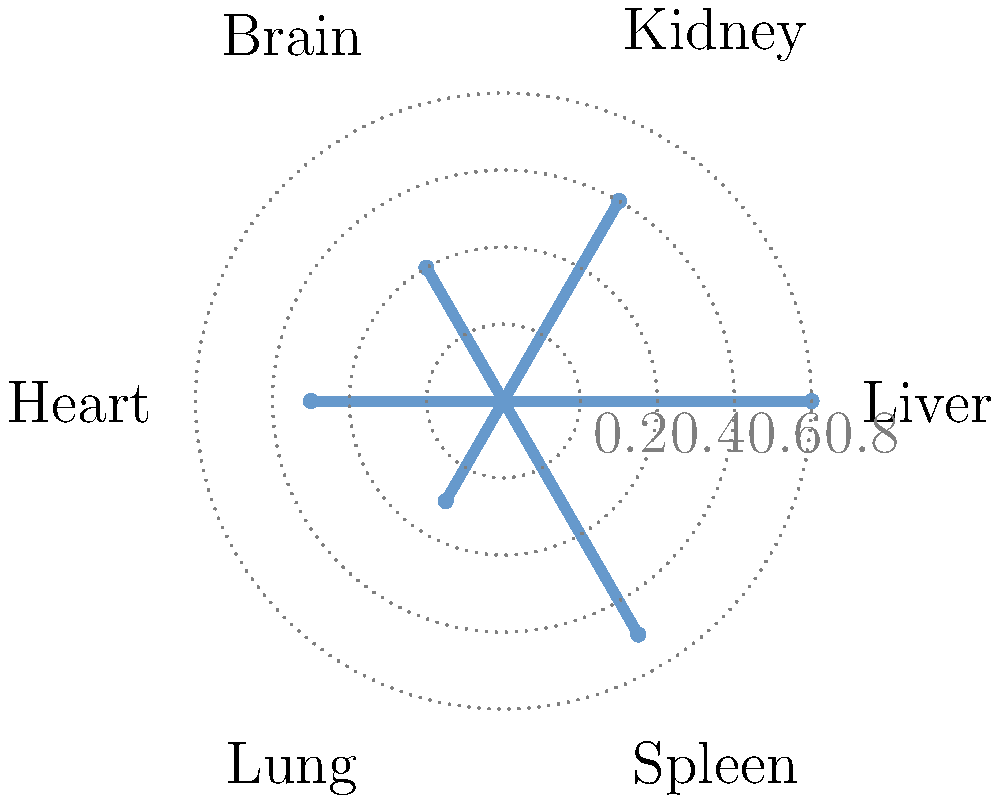Analyze the radial plot representing the distribution of a novel psychoactive drug's metabolites in various organs. Which organ shows the highest concentration of metabolites, and what implications might this have for the drug's potential side effects and therapeutic applications? To answer this question, we need to follow these steps:

1. Interpret the radial plot:
   - Each spoke represents a different organ
   - The distance from the center indicates the concentration of metabolites

2. Identify the organs and their corresponding metabolite concentrations:
   - Liver: 0.8
   - Kidney: 0.6
   - Brain: 0.4
   - Heart: 0.5
   - Lung: 0.3
   - Spleen: 0.7

3. Determine the organ with the highest concentration:
   - The liver shows the highest concentration at 0.8

4. Consider the implications:
   a) Side effects:
      - High liver concentration may indicate potential hepatotoxicity
      - Liver function tests may be necessary during treatment
   b) Therapeutic applications:
      - The drug may be effective for liver-related conditions
      - The high liver concentration suggests the drug undergoes significant hepatic metabolism

5. Note other significant concentrations:
   - Spleen (0.7) and kidney (0.6) also show relatively high concentrations
   - This may indicate potential effects on the immune system and renal function

6. Consider the brain concentration (0.4):
   - Moderate concentration suggests the drug can cross the blood-brain barrier
   - This property could be relevant for neuropsychiatric applications

The high liver concentration implies a need for careful monitoring of liver function during treatment and potential applications in liver-related disorders. The drug's ability to cross the blood-brain barrier suggests possible neuropsychiatric uses, while its presence in other organs indicates a need for comprehensive safety profiling.
Answer: Liver; potential hepatotoxicity and liver-targeted therapies, with neuropsychiatric applications due to blood-brain barrier penetration. 